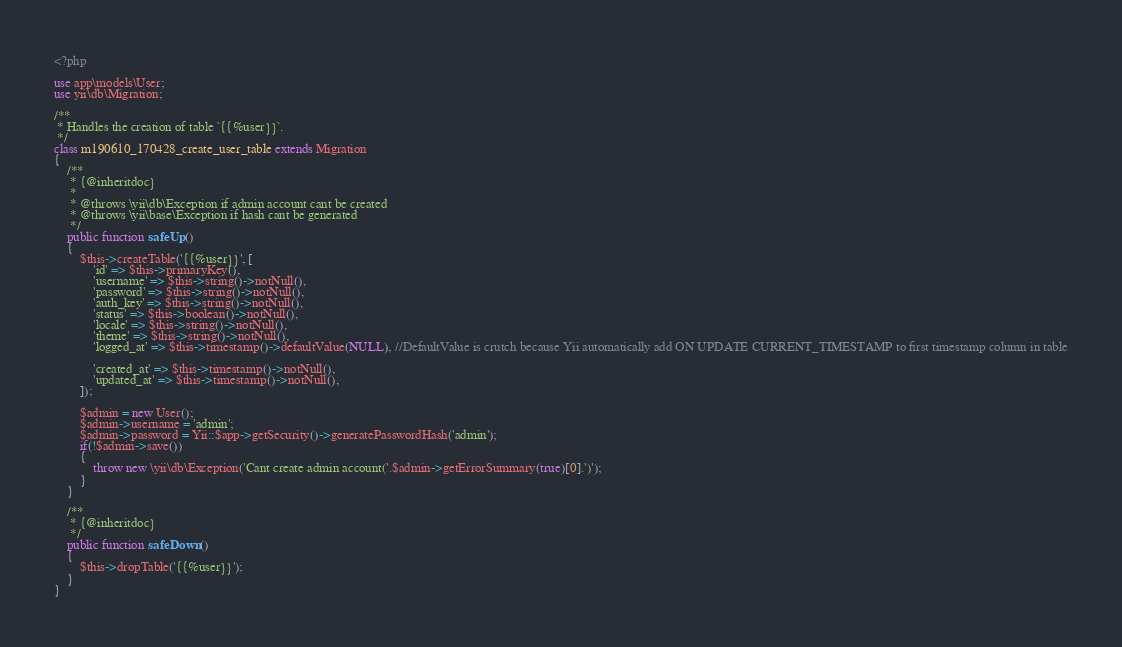Convert code to text. <code><loc_0><loc_0><loc_500><loc_500><_PHP_><?php

use app\models\User;
use yii\db\Migration;

/**
 * Handles the creation of table `{{%user}}`.
 */
class m190610_170428_create_user_table extends Migration
{
    /**
     * {@inheritdoc}
     *
     * @throws \yii\db\Exception if admin account cant be created
     * @throws \yii\base\Exception if hash cant be generated
     */
    public function safeUp()
    {
        $this->createTable('{{%user}}', [
            'id' => $this->primaryKey(),
            'username' => $this->string()->notNull(),
            'password' => $this->string()->notNull(),
            'auth_key' => $this->string()->notNull(),
            'status' => $this->boolean()->notNull(),
            'locale' => $this->string()->notNull(),
            'theme' => $this->string()->notNull(),
            'logged_at' => $this->timestamp()->defaultValue(NULL), //DefaultValue is crutch because Yii automatically add ON UPDATE CURRENT_TIMESTAMP to first timestamp column in table

            'created_at' => $this->timestamp()->notNull(),
            'updated_at' => $this->timestamp()->notNull(),
        ]);

        $admin = new User();
        $admin->username = 'admin';
        $admin->password = Yii::$app->getSecurity()->generatePasswordHash('admin');
        if(!$admin->save())
        {
            throw new \yii\db\Exception('Cant create admin account('.$admin->getErrorSummary(true)[0].')');
        }
    }

    /**
     * {@inheritdoc}
     */
    public function safeDown()
    {
        $this->dropTable('{{%user}}');
    }
}
</code> 